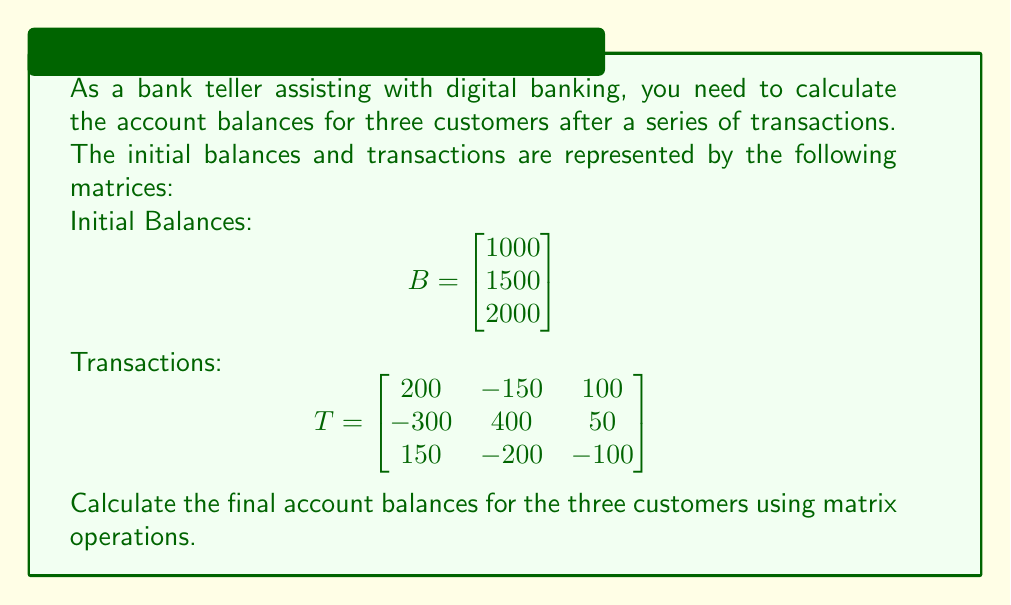Solve this math problem. To solve this problem, we need to add the initial balances to the sum of all transactions for each customer. We can do this using matrix addition.

Step 1: Calculate the sum of transactions for each customer.
We need to sum each row of the transaction matrix T. This can be done by multiplying T by a column vector of ones:

$$\begin{bmatrix} 
200 & -150 & 100 \\
-300 & 400 & 50 \\
150 & -200 & -100
\end{bmatrix} \times \begin{bmatrix} 1 \\ 1 \\ 1 \end{bmatrix} = \begin{bmatrix} 
200 - 150 + 100 \\
-300 + 400 + 50 \\
150 - 200 - 100
\end{bmatrix} = \begin{bmatrix} 150 \\ 150 \\ -150 \end{bmatrix}$$

Step 2: Add the sum of transactions to the initial balances.
We can now add this result to the initial balance matrix B:

$$\begin{bmatrix} 1000 \\ 1500 \\ 2000 \end{bmatrix} + \begin{bmatrix} 150 \\ 150 \\ -150 \end{bmatrix} = \begin{bmatrix} 1150 \\ 1650 \\ 1850 \end{bmatrix}$$

Therefore, the final account balances for the three customers are $1150, $1650, and $1850 respectively.
Answer: $$\begin{bmatrix} 1150 \\ 1650 \\ 1850 \end{bmatrix}$$ 